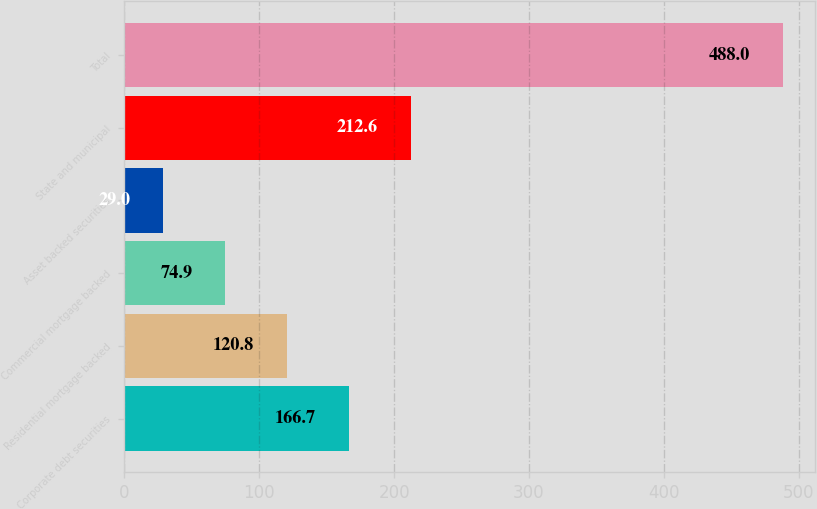Convert chart. <chart><loc_0><loc_0><loc_500><loc_500><bar_chart><fcel>Corporate debt securities<fcel>Residential mortgage backed<fcel>Commercial mortgage backed<fcel>Asset backed securities<fcel>State and municipal<fcel>Total<nl><fcel>166.7<fcel>120.8<fcel>74.9<fcel>29<fcel>212.6<fcel>488<nl></chart> 